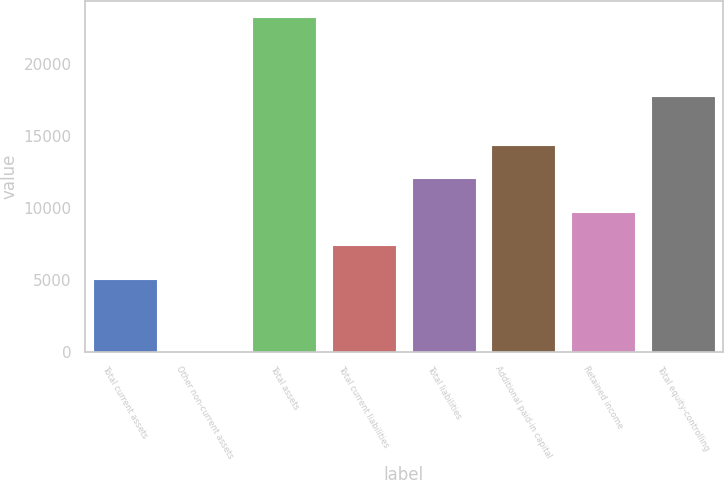<chart> <loc_0><loc_0><loc_500><loc_500><bar_chart><fcel>Total current assets<fcel>Other non-current assets<fcel>Total assets<fcel>Total current liabilities<fcel>Total liabilities<fcel>Additional paid-in capital<fcel>Retained income<fcel>Total equity-controlling<nl><fcel>5079<fcel>1<fcel>23283<fcel>7407.2<fcel>12063.6<fcel>14391.8<fcel>9735.4<fcel>17795<nl></chart> 